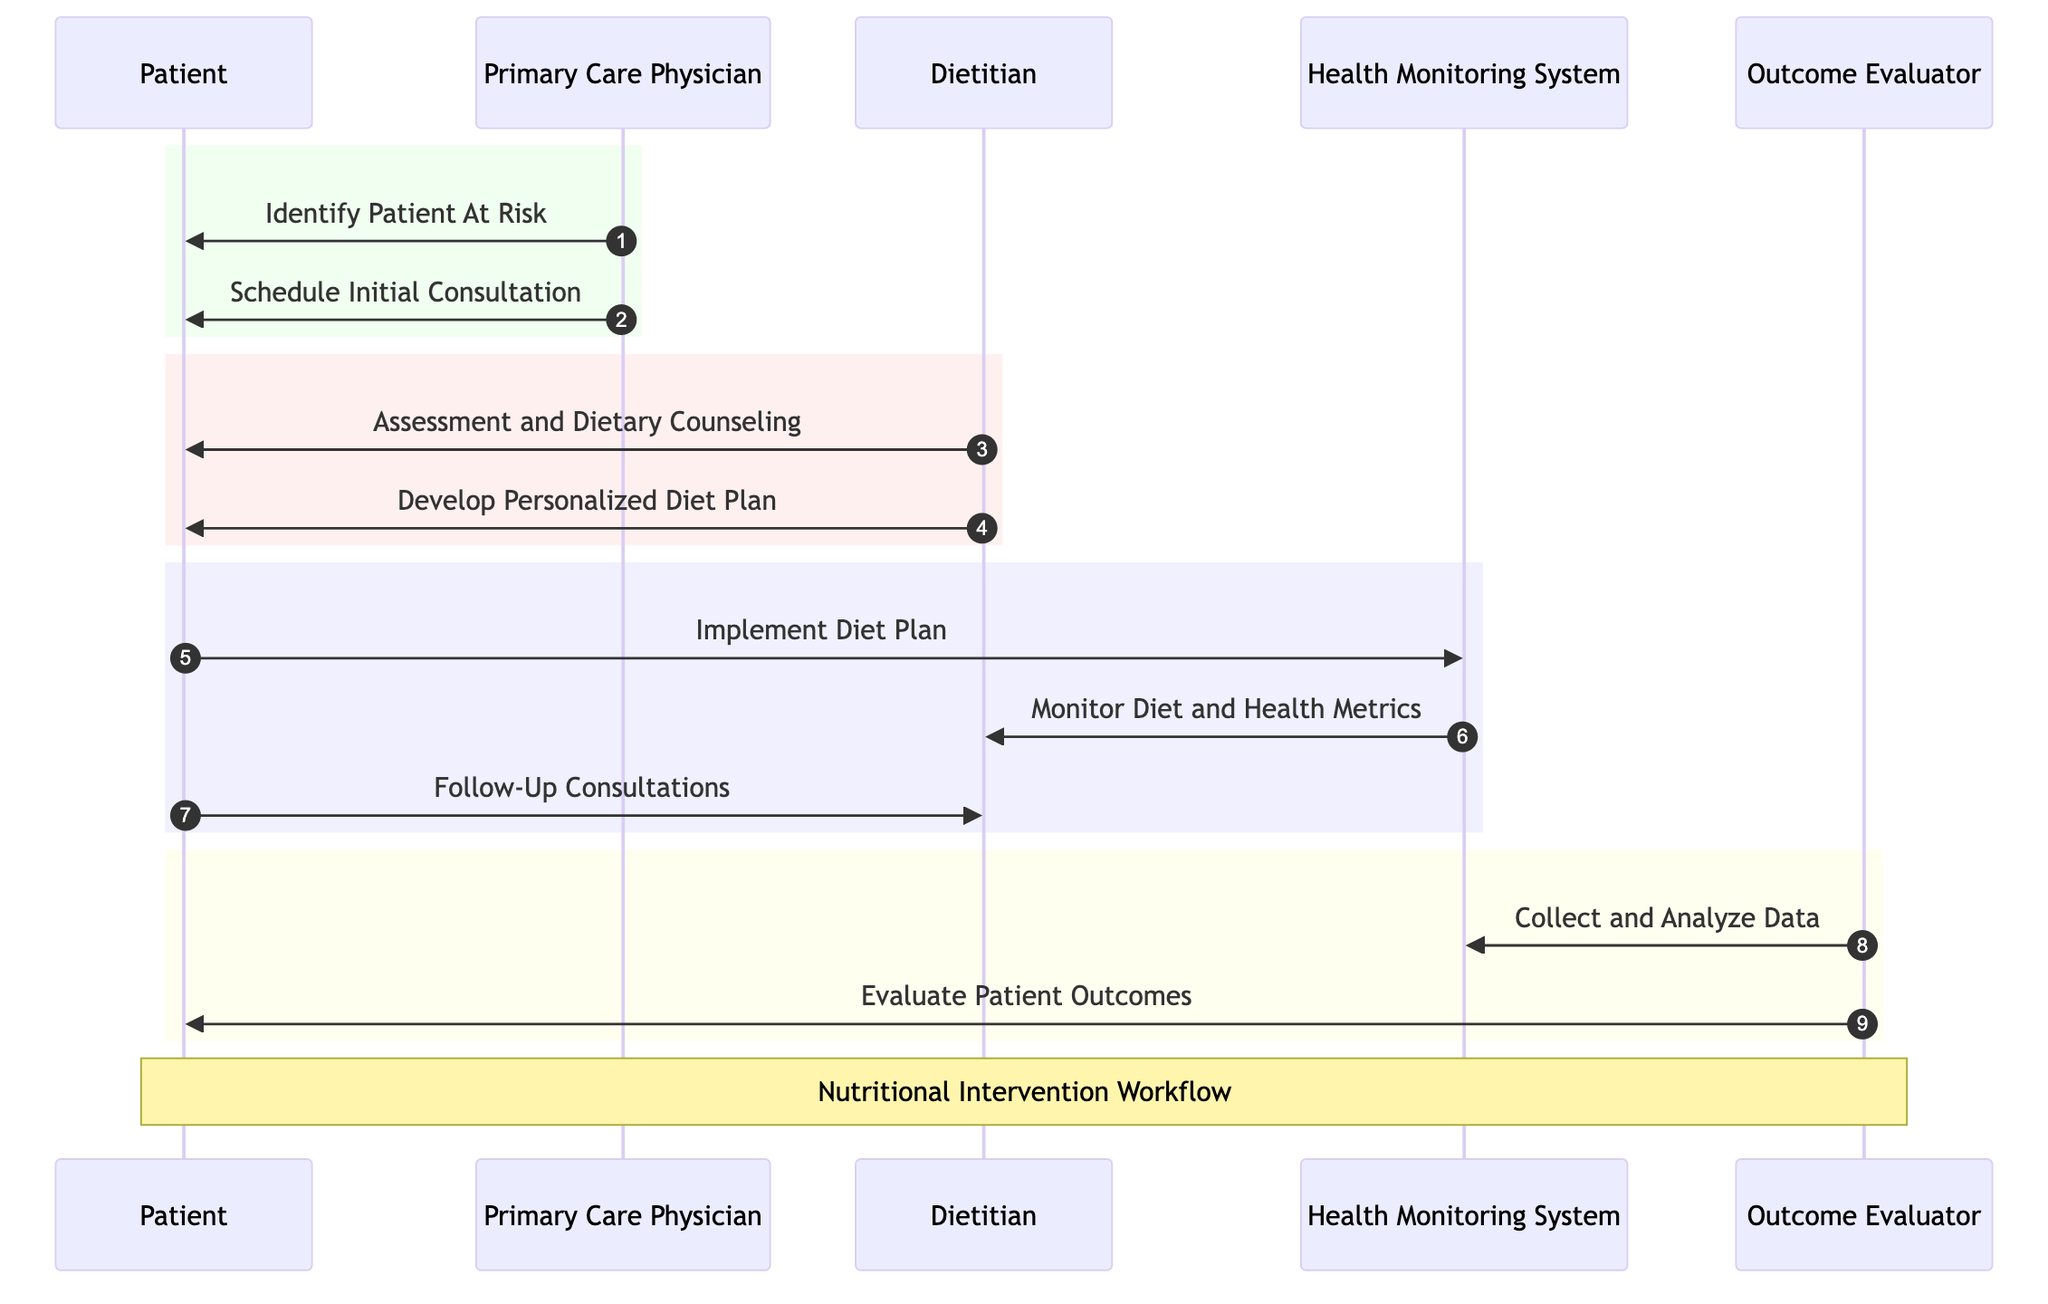What are the actors involved in the Nutritional Intervention Workflow? The diagram identifies five actors: Patient, Primary Care Physician, Dietitian, Health Monitoring System, and Outcome Evaluator.
Answer: Patient, Primary Care Physician, Dietitian, Health Monitoring System, Outcome Evaluator How many interactions are there in the workflow? By counting the arrows connecting the actors, the diagram displays a total of nine interactions, each representing communication or action taken between the actors.
Answer: Nine Which actor is responsible for implementing the diet plan? The arrow from Patient to Health Monitoring System indicates that the Patient is the one who implements the Diet Plan by interacting with the Health Monitoring System.
Answer: Patient Who evaluates the patient outcomes? The arrow directed from Outcome Evaluator to Patient shows that the Outcome Evaluator is responsible for evaluating the patient outcomes in the workflow.
Answer: Outcome Evaluator What message is sent from the Dietitian to the Patient after the dietary counseling? The message "Develop Personalized Diet Plan" is sent from the Dietitian to the Patient, indicating the actions taken after the counseling session.
Answer: Develop Personalized Diet Plan What does the Health Monitoring System do after the Patient implements the diet plan? Once the Patient implements the diet plan, the Health Monitoring System monitors diet and health metrics, as indicated by the arrow going from Health Monitoring System to Dietitian.
Answer: Monitor Diet and Health Metrics Which actor is involved in both dietary counseling and follow-up consultations? The Dietitian is involved in both processes, as evidenced by the direct interactions with the Patient regarding "Assessment and Dietary Counseling" and "Follow-Up Consultations."
Answer: Dietitian What colors are used to group different phases in the diagram? The diagram uses green for the Primary Care Physician's phase, red for the Dietitian’s phase, blue for the Patient’s interaction with the Health Monitoring System, and yellow for the Outcome Evaluator's phase.
Answer: Green, red, blue, yellow How is the flow of information structured in this sequence diagram? The diagram presents a sequential flow of information where actions are represented by arrows moving from the initiating actor to the responding actor, following a logical order of the intervention process.
Answer: Sequential flow 